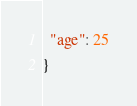Convert code to text. <code><loc_0><loc_0><loc_500><loc_500><_JavaScript_>  "age": 25
}</code> 